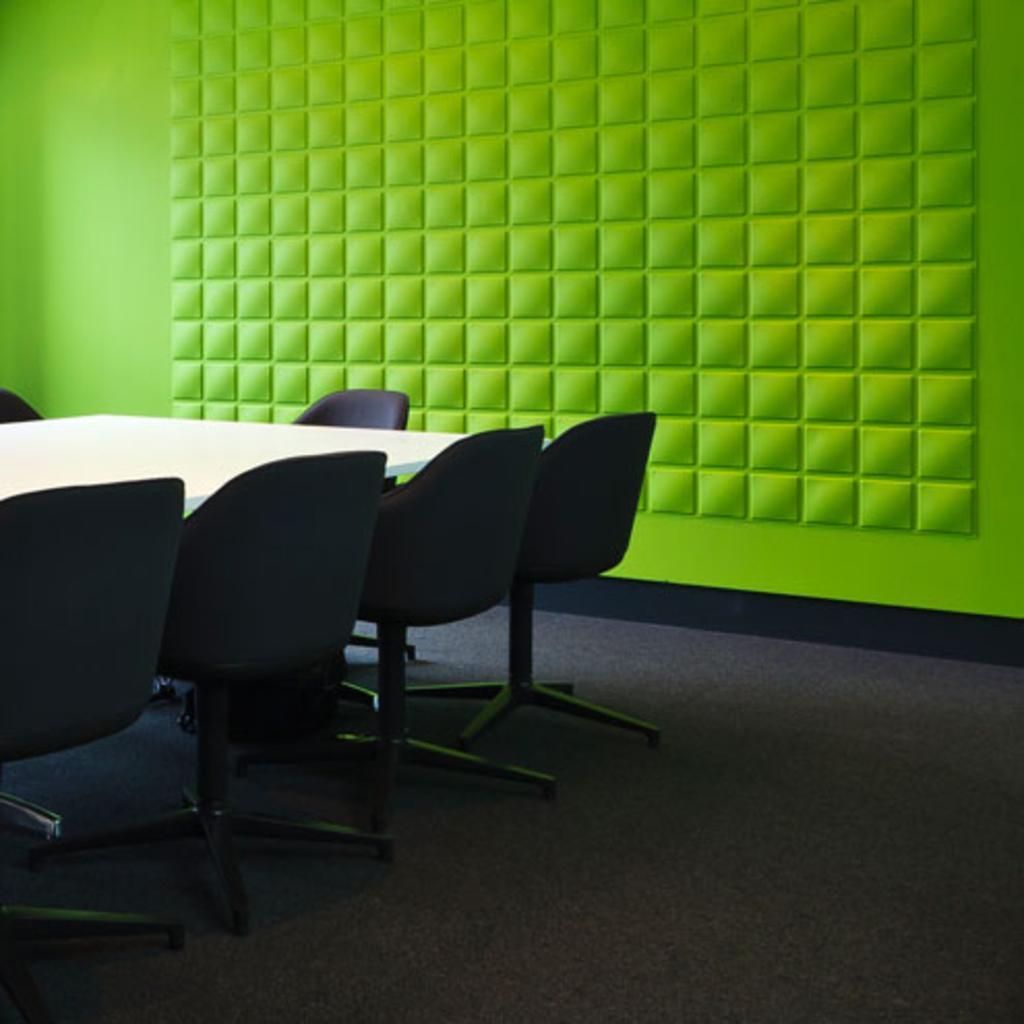How would you summarize this image in a sentence or two? In this picture, we see six chairs. These chairs are placed around the white table. These chairs are in black color. Behind that, we see a wall in green color. This picture might be clicked in the conference hall. At the bottom of the picture, we see a black color carpet. 